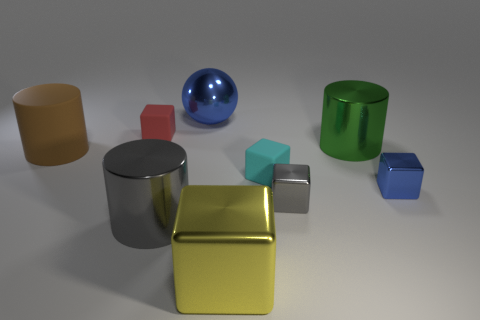There is a green metal cylinder; are there any tiny cyan things behind it?
Provide a succinct answer. No. Does the gray cylinder have the same size as the gray thing on the right side of the big ball?
Give a very brief answer. No. There is another shiny thing that is the same shape as the big gray object; what is its size?
Provide a short and direct response. Large. Is there any other thing that is made of the same material as the big brown thing?
Offer a terse response. Yes. There is a matte cube that is to the left of the cyan rubber cube; does it have the same size as the thing behind the tiny red thing?
Give a very brief answer. No. How many small things are cyan cubes or yellow shiny cylinders?
Your answer should be compact. 1. How many small blocks are both in front of the small blue object and on the right side of the gray metal cube?
Ensure brevity in your answer.  0. Do the green thing and the large cylinder in front of the brown matte object have the same material?
Make the answer very short. Yes. How many gray objects are cylinders or large metal objects?
Provide a short and direct response. 1. Are there any things of the same size as the shiny sphere?
Your response must be concise. Yes. 